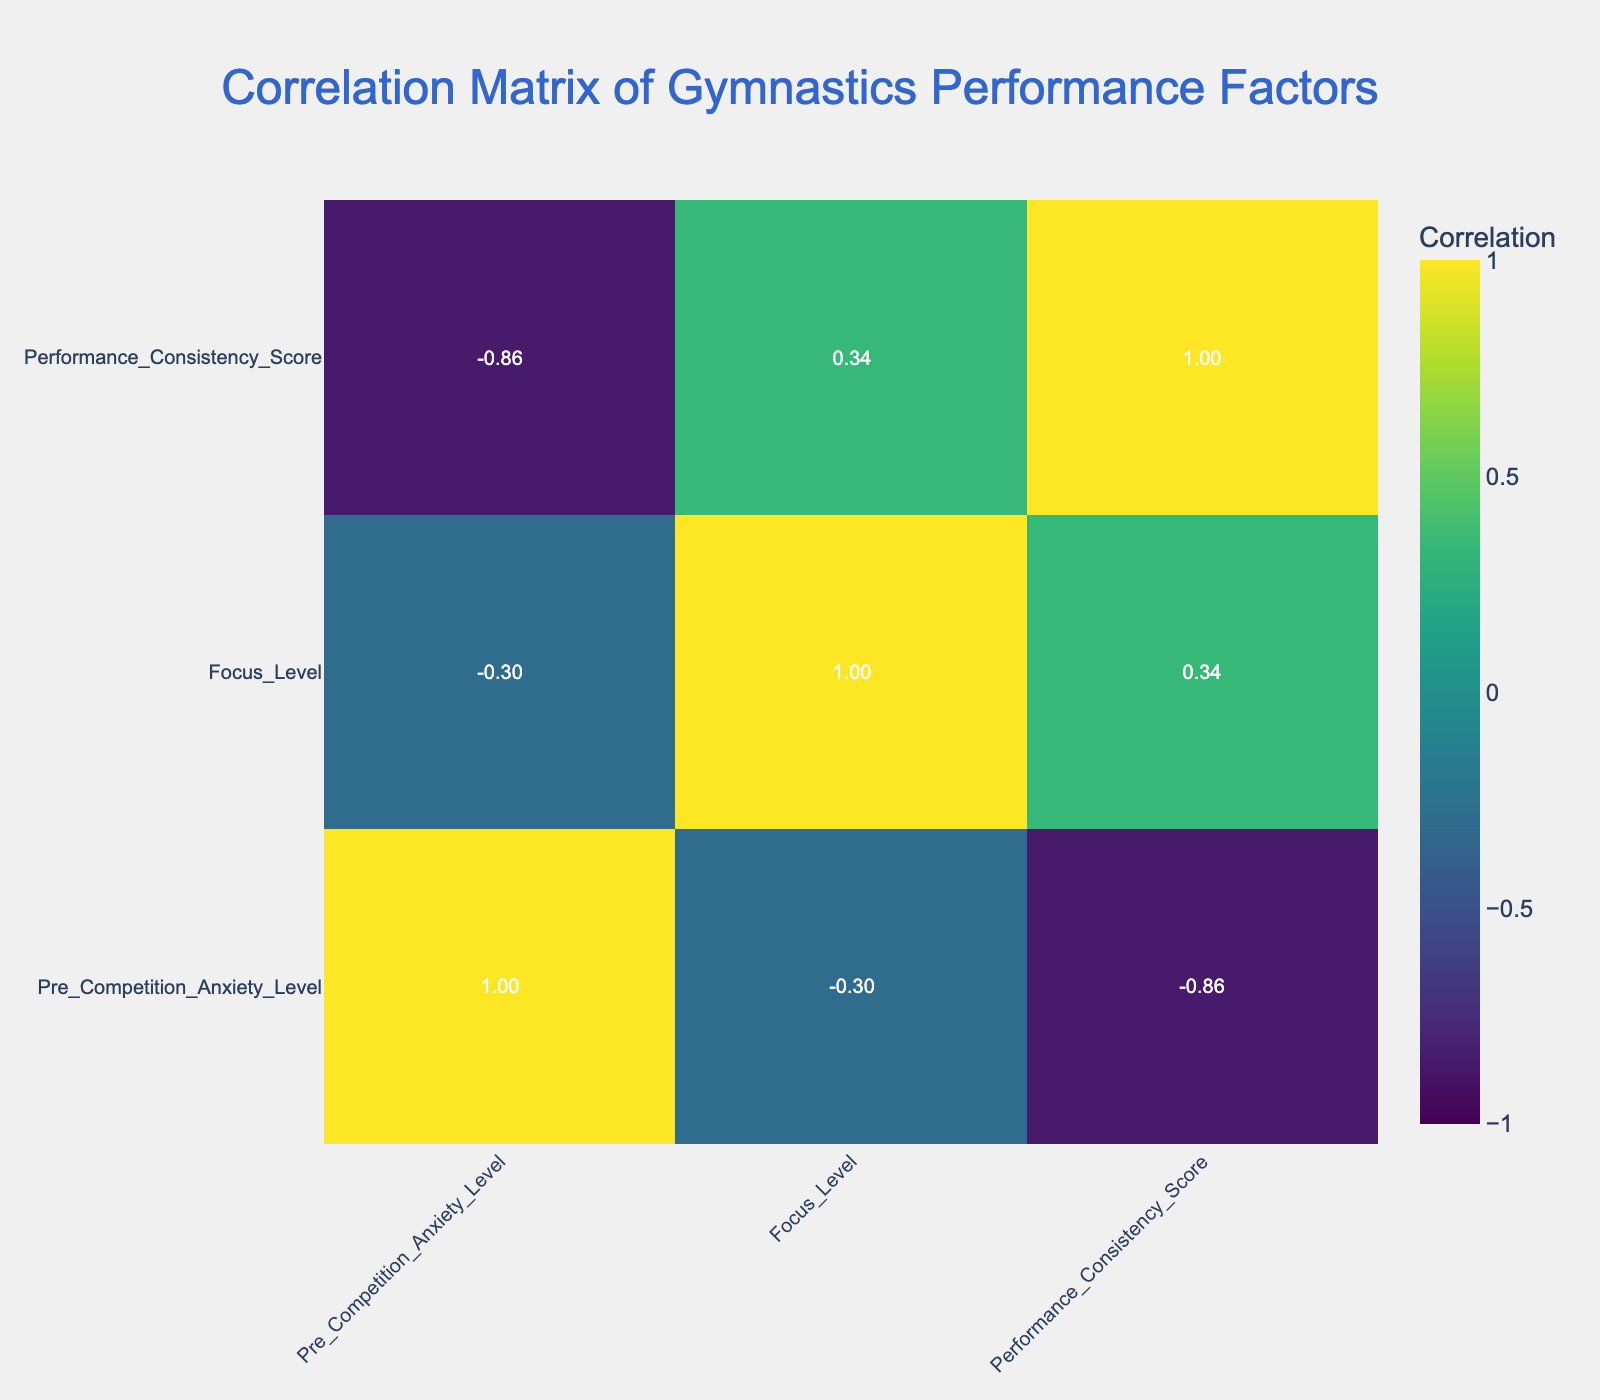What is the highest Performance Consistency Score in the table? The highest Performance Consistency Score in the table is 10, which corresponds to Zoe Martinez and Lucas Garcia, both practicing Positive Self-Talk.
Answer: 10 What is the correlation between Pre Competition Anxiety Level and Performance Consistency Score? By examining the table, we see that as Pre Competition Anxiety Level increases, the Performance Consistency Scores tend to decrease. A numerical assessment of the coefficient will confirm that this correlation is negative.
Answer: Negative correlation Which athlete has the lowest Focus Level and what is their Performance Consistency Score? Sophia Lee has the lowest Focus Level of 6, with a Performance Consistency Score of 6 as well.
Answer: Sophia Lee, 6 What is the average Focus Level of the athletes using Breathing Exercises? The Focus Levels for the athletes using Breathing Exercises are 8 and 7. The average is calculated as (8 + 7) / 2 = 7.5.
Answer: 7.5 Is there a positive correlation between Focus Level and Performance Consistency Score? To determine this, we look for a trend in the data. A higher Focus Level typically aligns with a higher Performance Consistency Score, indicating a positive correlation. This can be confirmed by looking at the correlation value for these two columns.
Answer: Yes 